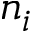<formula> <loc_0><loc_0><loc_500><loc_500>n _ { i }</formula> 